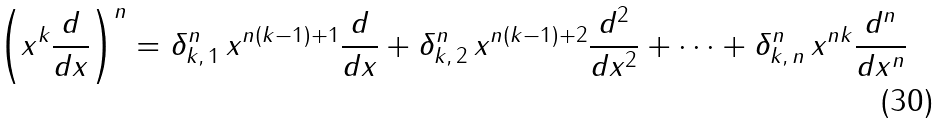<formula> <loc_0><loc_0><loc_500><loc_500>\left ( x ^ { k } \frac { d } { d x } \right ) ^ { n } = \delta _ { k , \, 1 } ^ { n } \, x ^ { n ( k - 1 ) + 1 } \frac { d } { d x } + \delta _ { k , \, 2 } ^ { n } \, x ^ { n ( k - 1 ) + 2 } \frac { d ^ { 2 } } { d x ^ { 2 } } + \cdots + \delta _ { k , \, n } ^ { n } \, x ^ { n k } \frac { d ^ { n } } { d x ^ { n } }</formula> 